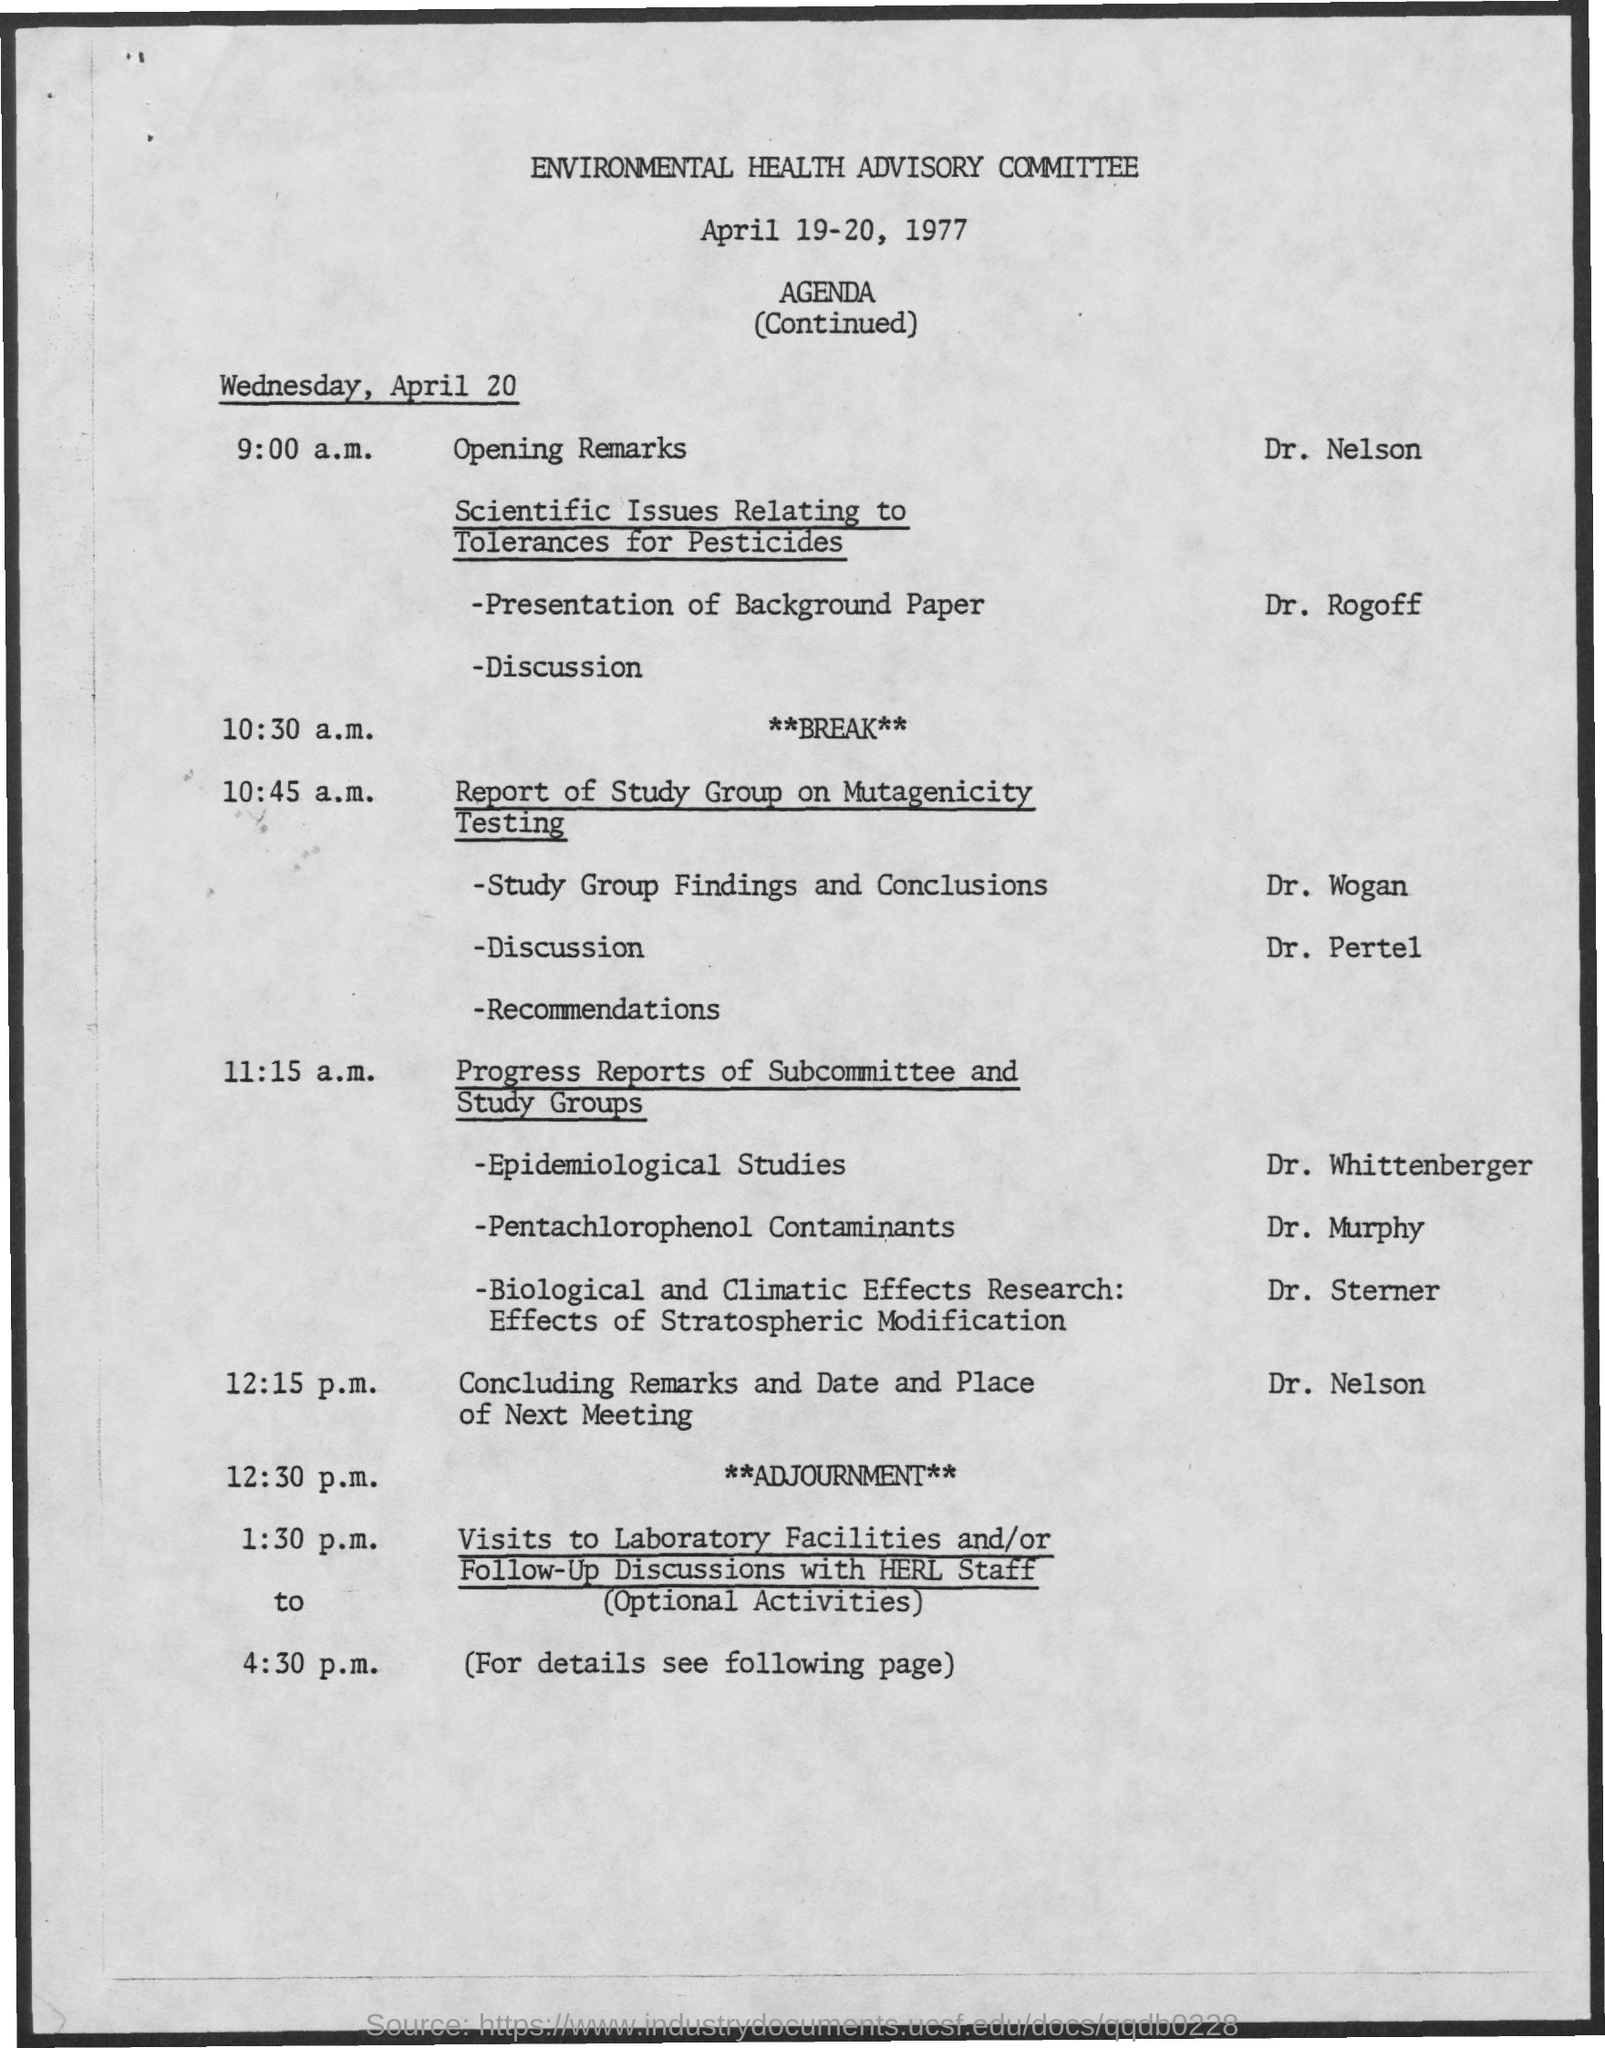Point out several critical features in this image. Dr. Nelson is presenting the opening remarks. On April 19-20, 1977, the Environmental Health Advisory Committee was held. The presentation on Pentachlorophenol contaminants will be given by Dr. Murphy. The visits to laboratory facilities are scheduled from 1:30 p.m. to 4:30 p.m. The speaker of the presentation on the background paper is Dr. Rogoff. 